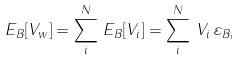Convert formula to latex. <formula><loc_0><loc_0><loc_500><loc_500>E _ { B } [ V _ { w } ] = \sum _ { i } ^ { N } \, E _ { B } [ V _ { i } ] = \sum _ { i } ^ { N } \, V _ { i } \, \varepsilon _ { { B } _ { i } }</formula> 